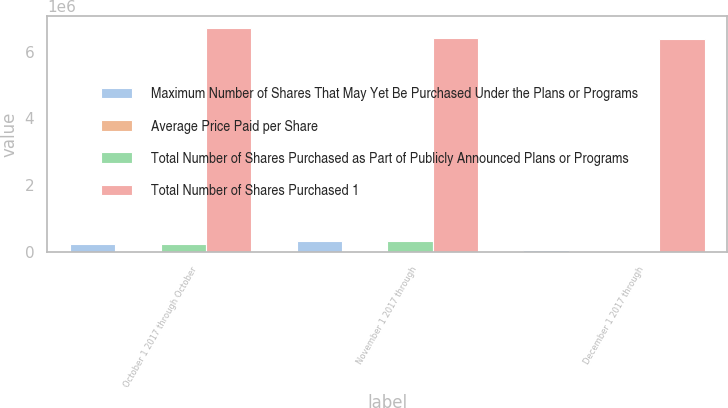Convert chart. <chart><loc_0><loc_0><loc_500><loc_500><stacked_bar_chart><ecel><fcel>October 1 2017 through October<fcel>November 1 2017 through<fcel>December 1 2017 through<nl><fcel>Maximum Number of Shares That May Yet Be Purchased Under the Plans or Programs<fcel>228894<fcel>327922<fcel>44772<nl><fcel>Average Price Paid per Share<fcel>474.49<fcel>477.02<fcel>508.97<nl><fcel>Total Number of Shares Purchased as Part of Publicly Announced Plans or Programs<fcel>218859<fcel>327228<fcel>29396<nl><fcel>Total Number of Shares Purchased 1<fcel>6.7238e+06<fcel>6.39657e+06<fcel>6.36717e+06<nl></chart> 